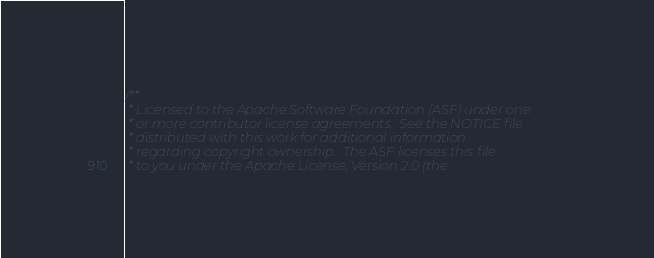<code> <loc_0><loc_0><loc_500><loc_500><_C++_>/**
 * Licensed to the Apache Software Foundation (ASF) under one
 * or more contributor license agreements.  See the NOTICE file
 * distributed with this work for additional information
 * regarding copyright ownership.  The ASF licenses this file
 * to you under the Apache License, Version 2.0 (the</code> 